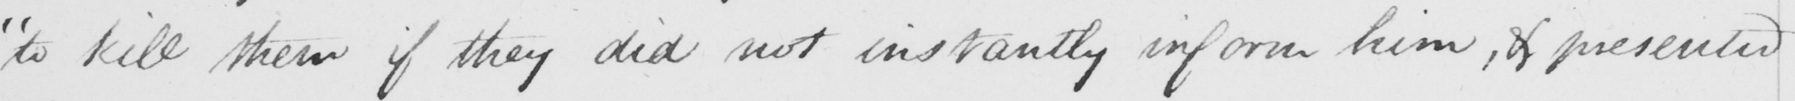Can you read and transcribe this handwriting? " to kill them if they did not instantly inform him , & presented 